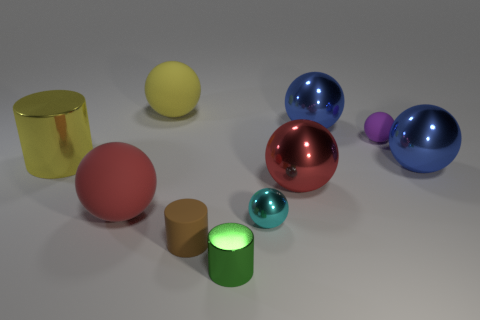Is the large blue object that is in front of the yellow shiny thing made of the same material as the small cyan object?
Ensure brevity in your answer.  Yes. Are there an equal number of yellow cylinders in front of the tiny brown matte thing and big yellow cylinders that are on the right side of the yellow shiny thing?
Make the answer very short. Yes. What is the shape of the object that is to the left of the large red metal thing and on the right side of the small green thing?
Offer a very short reply. Sphere. What number of balls are to the left of the tiny brown rubber cylinder?
Give a very brief answer. 2. How many other things are there of the same shape as the cyan thing?
Your answer should be compact. 6. Are there fewer large rubber objects than small purple matte objects?
Ensure brevity in your answer.  No. There is a sphere that is in front of the purple matte sphere and on the left side of the green cylinder; how big is it?
Your answer should be very brief. Large. There is a matte sphere that is on the right side of the tiny metallic object in front of the small cylinder that is to the left of the tiny metallic cylinder; how big is it?
Ensure brevity in your answer.  Small. The green cylinder is what size?
Offer a terse response. Small. Is there anything else that has the same material as the small cyan object?
Offer a terse response. Yes. 